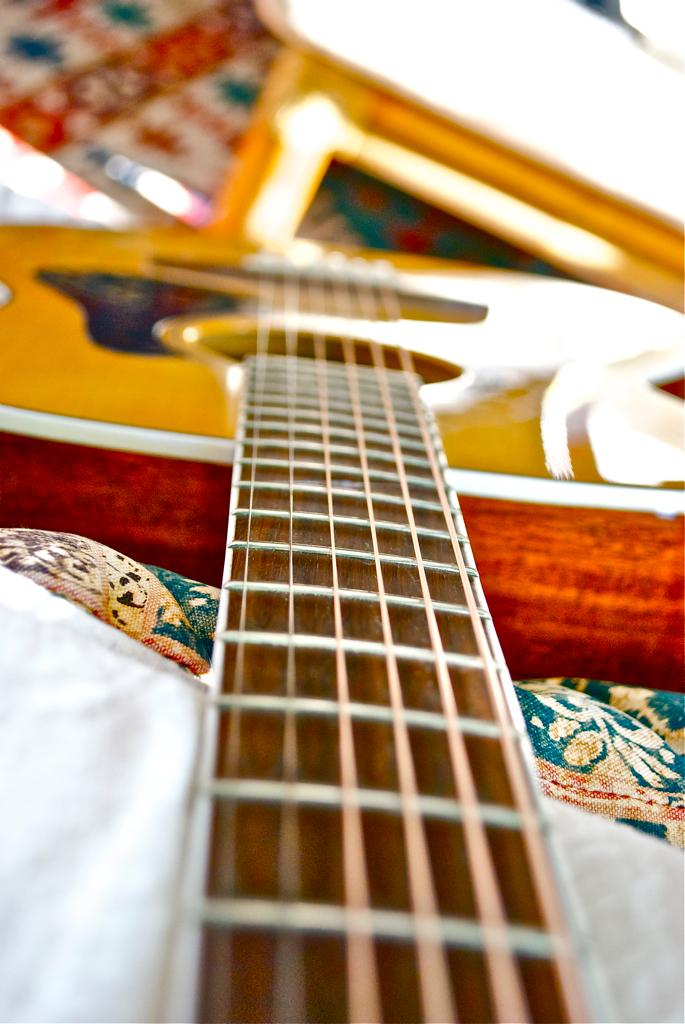What musical instrument is present in the image? There is a guitar in the image. What colors are used to paint the guitar? The guitar is red and yellow in color. How does the giraffe's knowledge of music contribute to the image? There is no giraffe present in the image, so its knowledge of music cannot contribute to the image. 